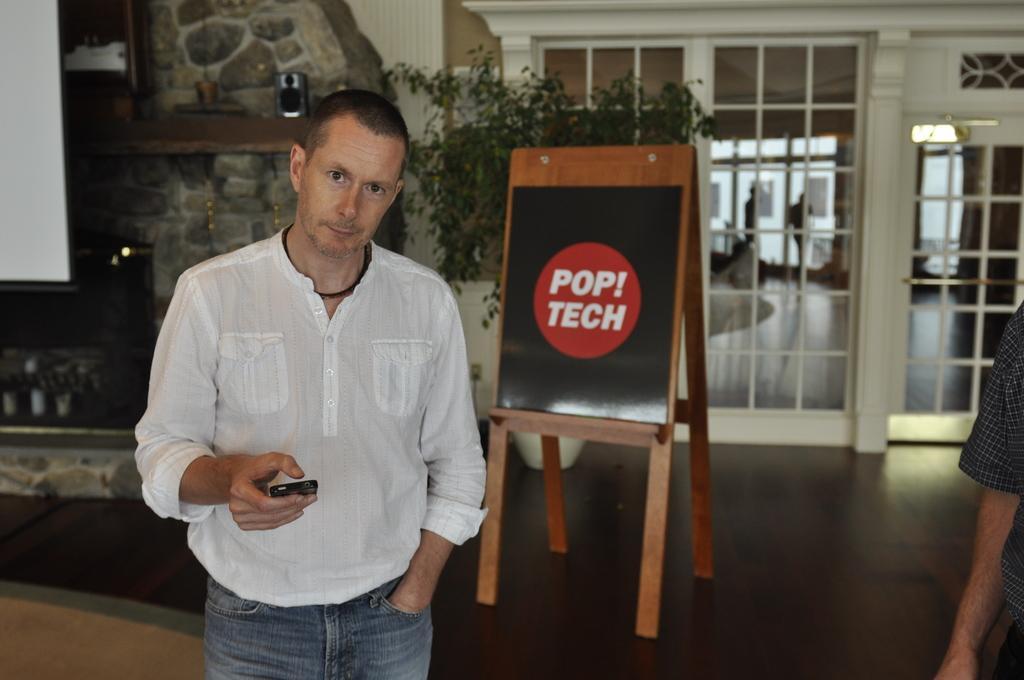Describe this image in one or two sentences. In this image, we can see a person wearing clothes and holding a phone with his hand. There is a board and plant in the middle of the image. There is a light in the top right of the image. There is a person hand in the bottom right of the image. 